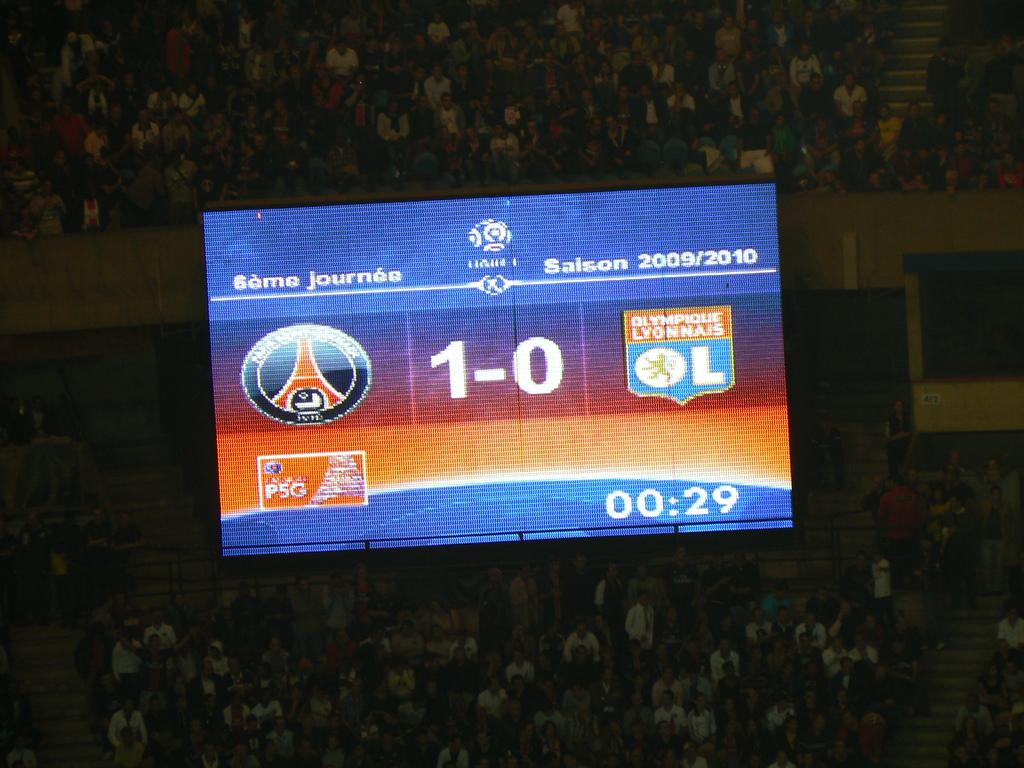Provide a one-sentence caption for the provided image. The score of an indoor sporting event is shown as 1-0 on the lit up scoreboard. 